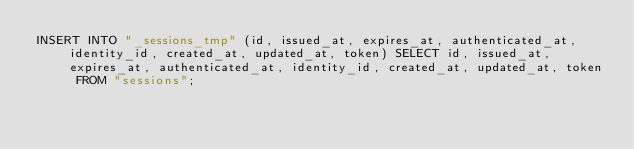<code> <loc_0><loc_0><loc_500><loc_500><_SQL_>INSERT INTO "_sessions_tmp" (id, issued_at, expires_at, authenticated_at, identity_id, created_at, updated_at, token) SELECT id, issued_at, expires_at, authenticated_at, identity_id, created_at, updated_at, token FROM "sessions";</code> 